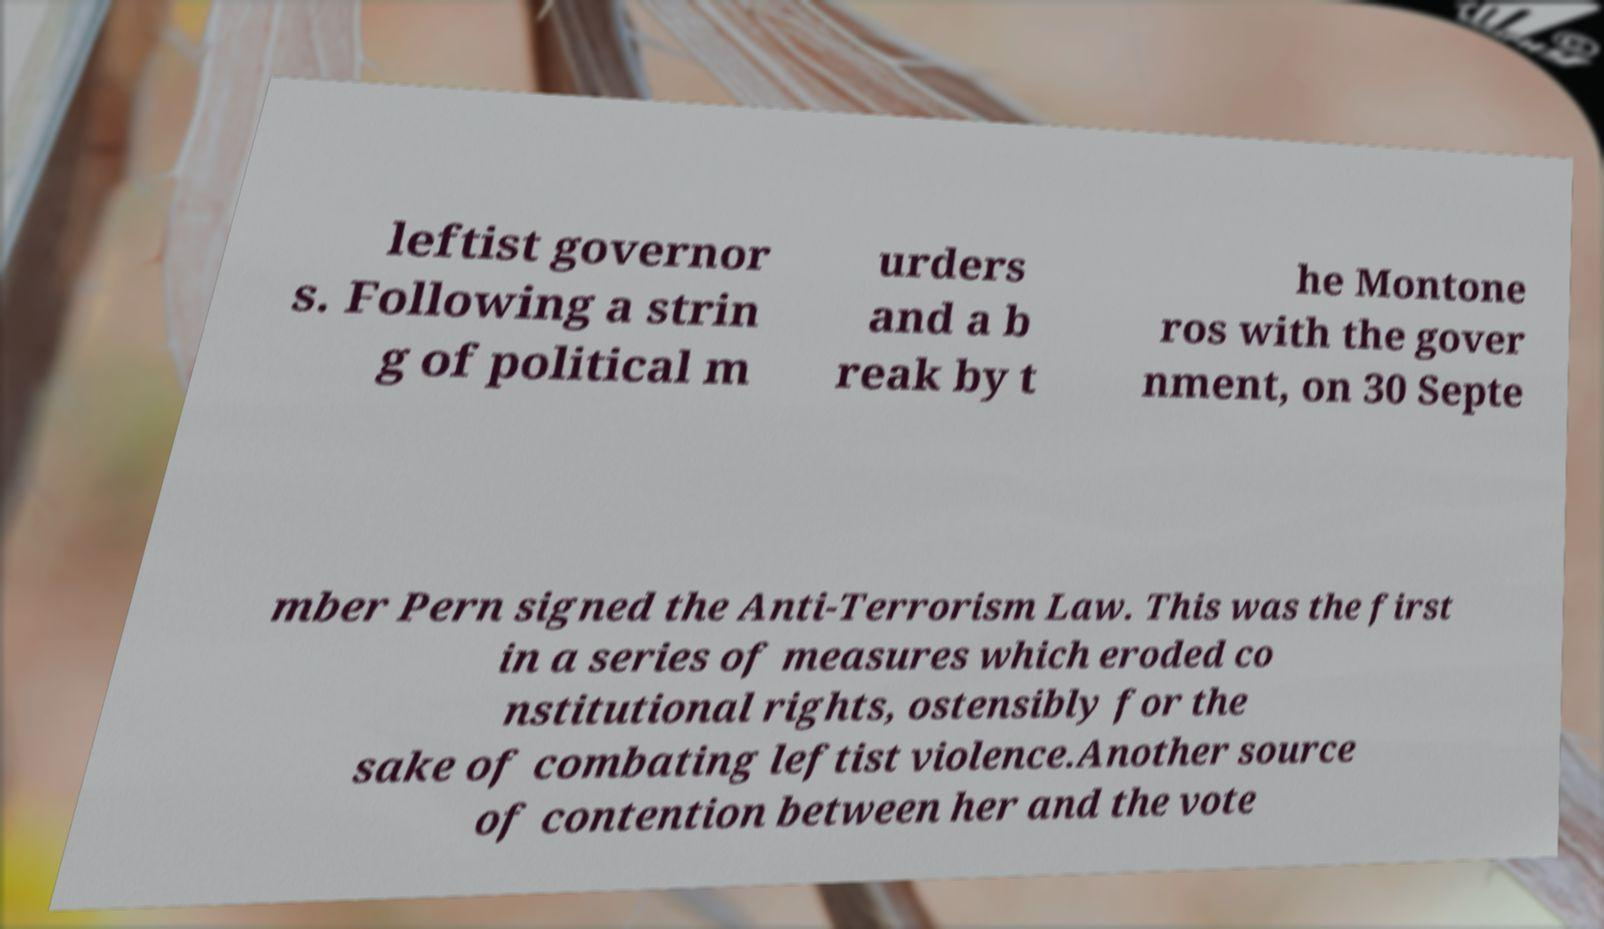For documentation purposes, I need the text within this image transcribed. Could you provide that? leftist governor s. Following a strin g of political m urders and a b reak by t he Montone ros with the gover nment, on 30 Septe mber Pern signed the Anti-Terrorism Law. This was the first in a series of measures which eroded co nstitutional rights, ostensibly for the sake of combating leftist violence.Another source of contention between her and the vote 